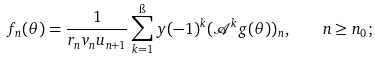Convert formula to latex. <formula><loc_0><loc_0><loc_500><loc_500>f _ { n } ( \theta ) = \frac { 1 } { r _ { n } v _ { n } u _ { n + 1 } } \sum _ { k = 1 } ^ { \i } y ( - 1 ) ^ { k } ( \mathcal { A } ^ { k } g ( \theta ) ) _ { n } , \quad n \geq n _ { 0 } ;</formula> 